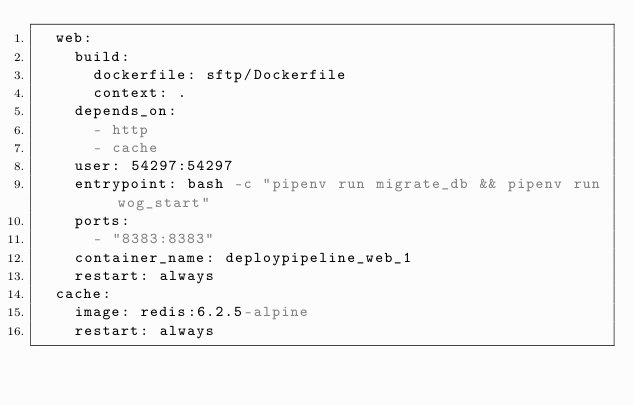Convert code to text. <code><loc_0><loc_0><loc_500><loc_500><_YAML_>  web:
    build:
      dockerfile: sftp/Dockerfile
      context: .
    depends_on:
      - http
      - cache
    user: 54297:54297
    entrypoint: bash -c "pipenv run migrate_db && pipenv run wog_start"
    ports:
      - "8383:8383"
    container_name: deploypipeline_web_1
    restart: always
  cache:
    image: redis:6.2.5-alpine
    restart: always
</code> 